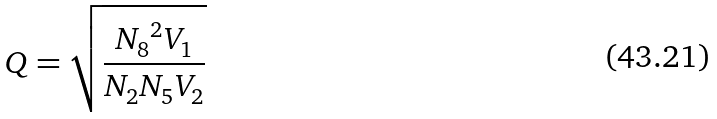<formula> <loc_0><loc_0><loc_500><loc_500>Q = \sqrt { \frac { { N _ { 8 } } ^ { 2 } V _ { 1 } } { N _ { 2 } N _ { 5 } V _ { 2 } } }</formula> 